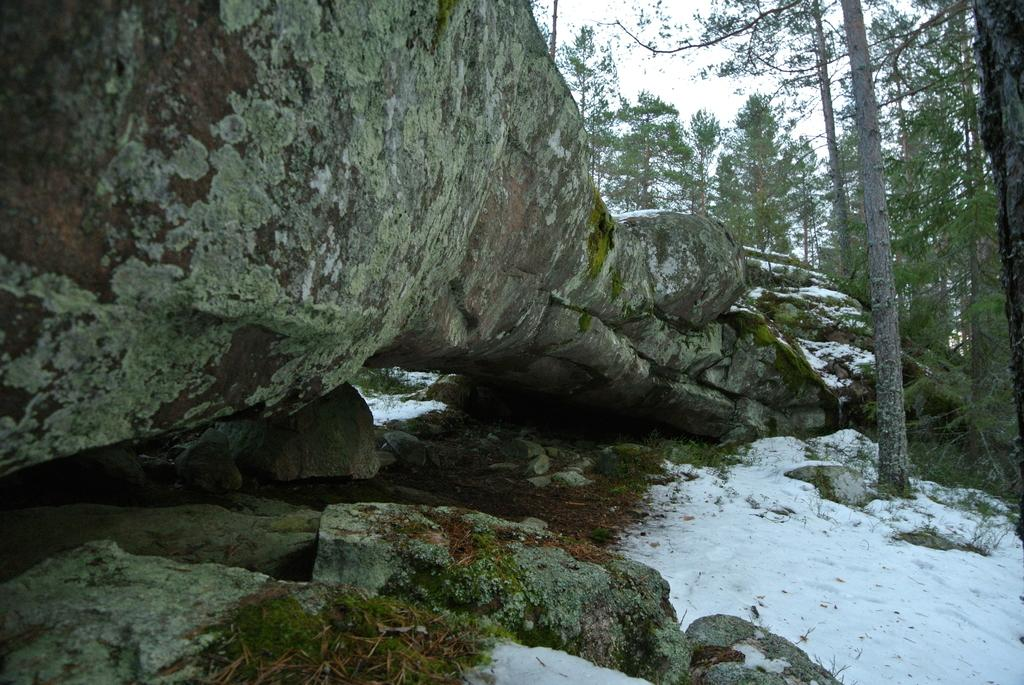What is the main feature in the image? There is a huge rock in the image. What is the ground condition around the rock? There is snow around the rock. What type of vegetation can be seen in the image? There are tall trees in the image. What type of flight is taking off from the rock in the image? There is no flight or any indication of a flight taking off from the rock in the image. 